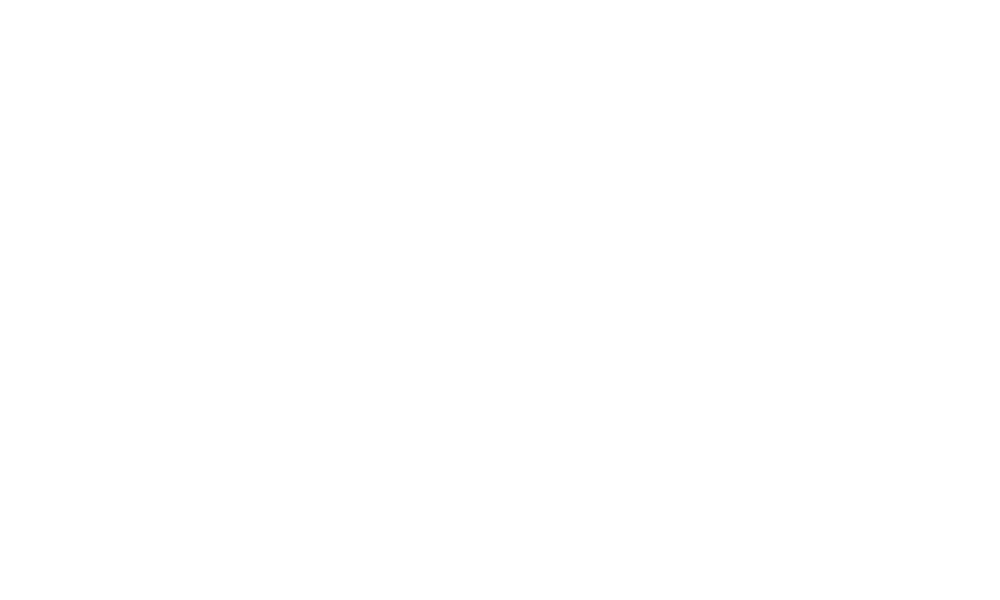Convert chart to OTSL. <chart><loc_0><loc_0><loc_500><loc_500><pie_chart><fcel>Brazil / India Corrugated<nl><fcel>100.0%<nl></chart> 